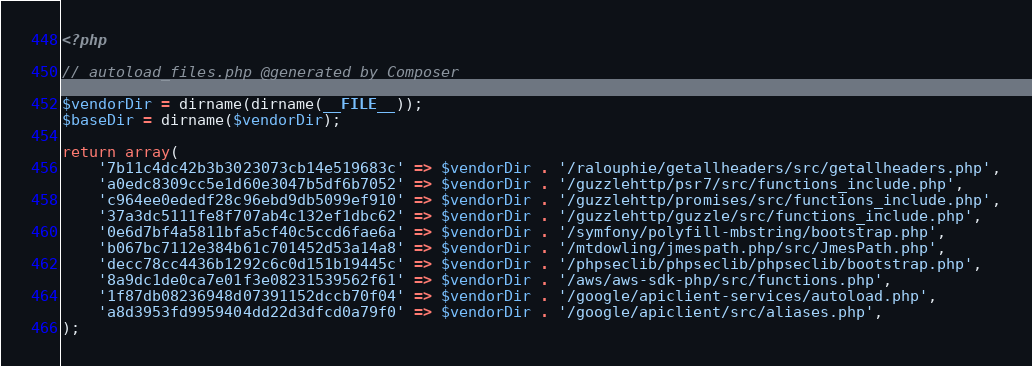Convert code to text. <code><loc_0><loc_0><loc_500><loc_500><_PHP_><?php

// autoload_files.php @generated by Composer

$vendorDir = dirname(dirname(__FILE__));
$baseDir = dirname($vendorDir);

return array(
    '7b11c4dc42b3b3023073cb14e519683c' => $vendorDir . '/ralouphie/getallheaders/src/getallheaders.php',
    'a0edc8309cc5e1d60e3047b5df6b7052' => $vendorDir . '/guzzlehttp/psr7/src/functions_include.php',
    'c964ee0ededf28c96ebd9db5099ef910' => $vendorDir . '/guzzlehttp/promises/src/functions_include.php',
    '37a3dc5111fe8f707ab4c132ef1dbc62' => $vendorDir . '/guzzlehttp/guzzle/src/functions_include.php',
    '0e6d7bf4a5811bfa5cf40c5ccd6fae6a' => $vendorDir . '/symfony/polyfill-mbstring/bootstrap.php',
    'b067bc7112e384b61c701452d53a14a8' => $vendorDir . '/mtdowling/jmespath.php/src/JmesPath.php',
    'decc78cc4436b1292c6c0d151b19445c' => $vendorDir . '/phpseclib/phpseclib/phpseclib/bootstrap.php',
    '8a9dc1de0ca7e01f3e08231539562f61' => $vendorDir . '/aws/aws-sdk-php/src/functions.php',
    '1f87db08236948d07391152dccb70f04' => $vendorDir . '/google/apiclient-services/autoload.php',
    'a8d3953fd9959404dd22d3dfcd0a79f0' => $vendorDir . '/google/apiclient/src/aliases.php',
);
</code> 